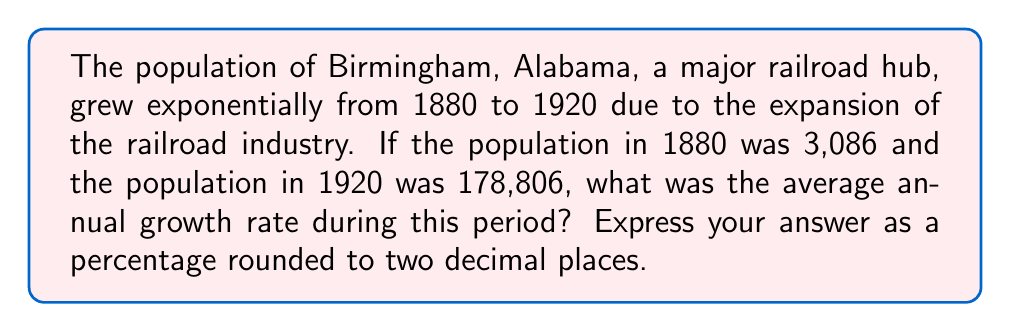Give your solution to this math problem. To solve this problem, we need to use the exponential growth formula:

$$P(t) = P_0 \cdot (1 + r)^t$$

Where:
$P(t)$ is the final population
$P_0$ is the initial population
$r$ is the annual growth rate
$t$ is the number of years

Given:
$P_0 = 3,086$ (population in 1880)
$P(t) = 178,806$ (population in 1920)
$t = 40$ years (1920 - 1880)

Let's substitute these values into the formula:

$$178,806 = 3,086 \cdot (1 + r)^{40}$$

Now, we need to solve for $r$:

1) Divide both sides by 3,086:
   $$(1 + r)^{40} = \frac{178,806}{3,086} \approx 57.9410$$

2) Take the 40th root of both sides:
   $$1 + r = \sqrt[40]{57.9410}$$

3) Subtract 1 from both sides:
   $$r = \sqrt[40]{57.9410} - 1$$

4) Calculate the result:
   $$r \approx 0.1048$$

5) Convert to a percentage:
   $$r \approx 10.48\%$$

Therefore, the average annual growth rate was approximately 10.48%.
Answer: 10.48% 